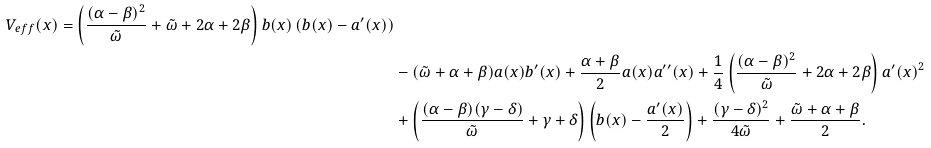Convert formula to latex. <formula><loc_0><loc_0><loc_500><loc_500>{ V _ { e f f } ( x ) = \left ( \frac { ( \alpha - \beta ) ^ { 2 } } { \tilde { \omega } } + \tilde { \omega } + 2 \alpha + 2 \beta \right ) b ( x ) \left ( b ( x ) - a ^ { \prime } ( x ) \right ) } \\ & - ( \tilde { \omega } + \alpha + \beta ) a ( x ) b ^ { \prime } ( x ) + \frac { \alpha + \beta } { 2 } a ( x ) a ^ { \prime \prime } ( x ) + \frac { 1 } { 4 } \left ( \frac { ( \alpha - \beta ) ^ { 2 } } { \tilde { \omega } } + 2 \alpha + 2 \beta \right ) a ^ { \prime } ( x ) ^ { 2 } \\ & + \left ( \frac { ( \alpha - \beta ) ( \gamma - \delta ) } { \tilde { \omega } } + \gamma + \delta \right ) \left ( b ( x ) - \frac { a ^ { \prime } ( x ) } { 2 } \right ) + \frac { ( \gamma - \delta ) ^ { 2 } } { 4 \tilde { \omega } } + \frac { \tilde { \omega } + \alpha + \beta } { 2 } .</formula> 